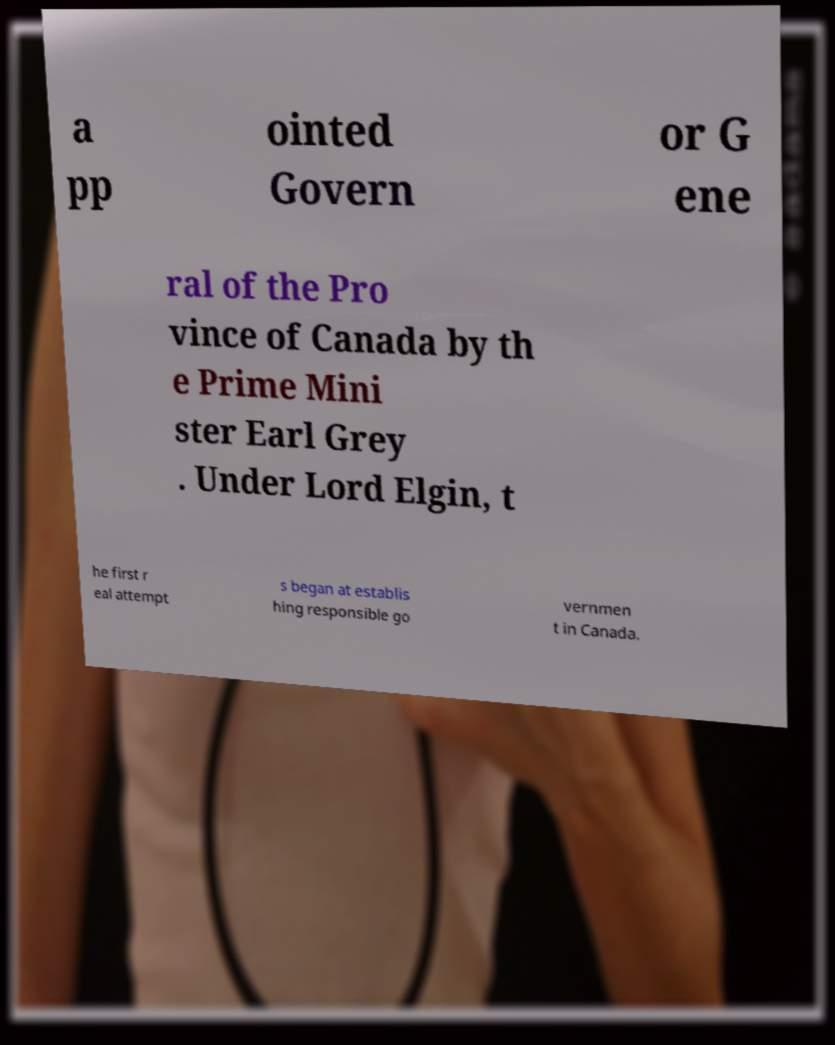I need the written content from this picture converted into text. Can you do that? a pp ointed Govern or G ene ral of the Pro vince of Canada by th e Prime Mini ster Earl Grey . Under Lord Elgin, t he first r eal attempt s began at establis hing responsible go vernmen t in Canada. 